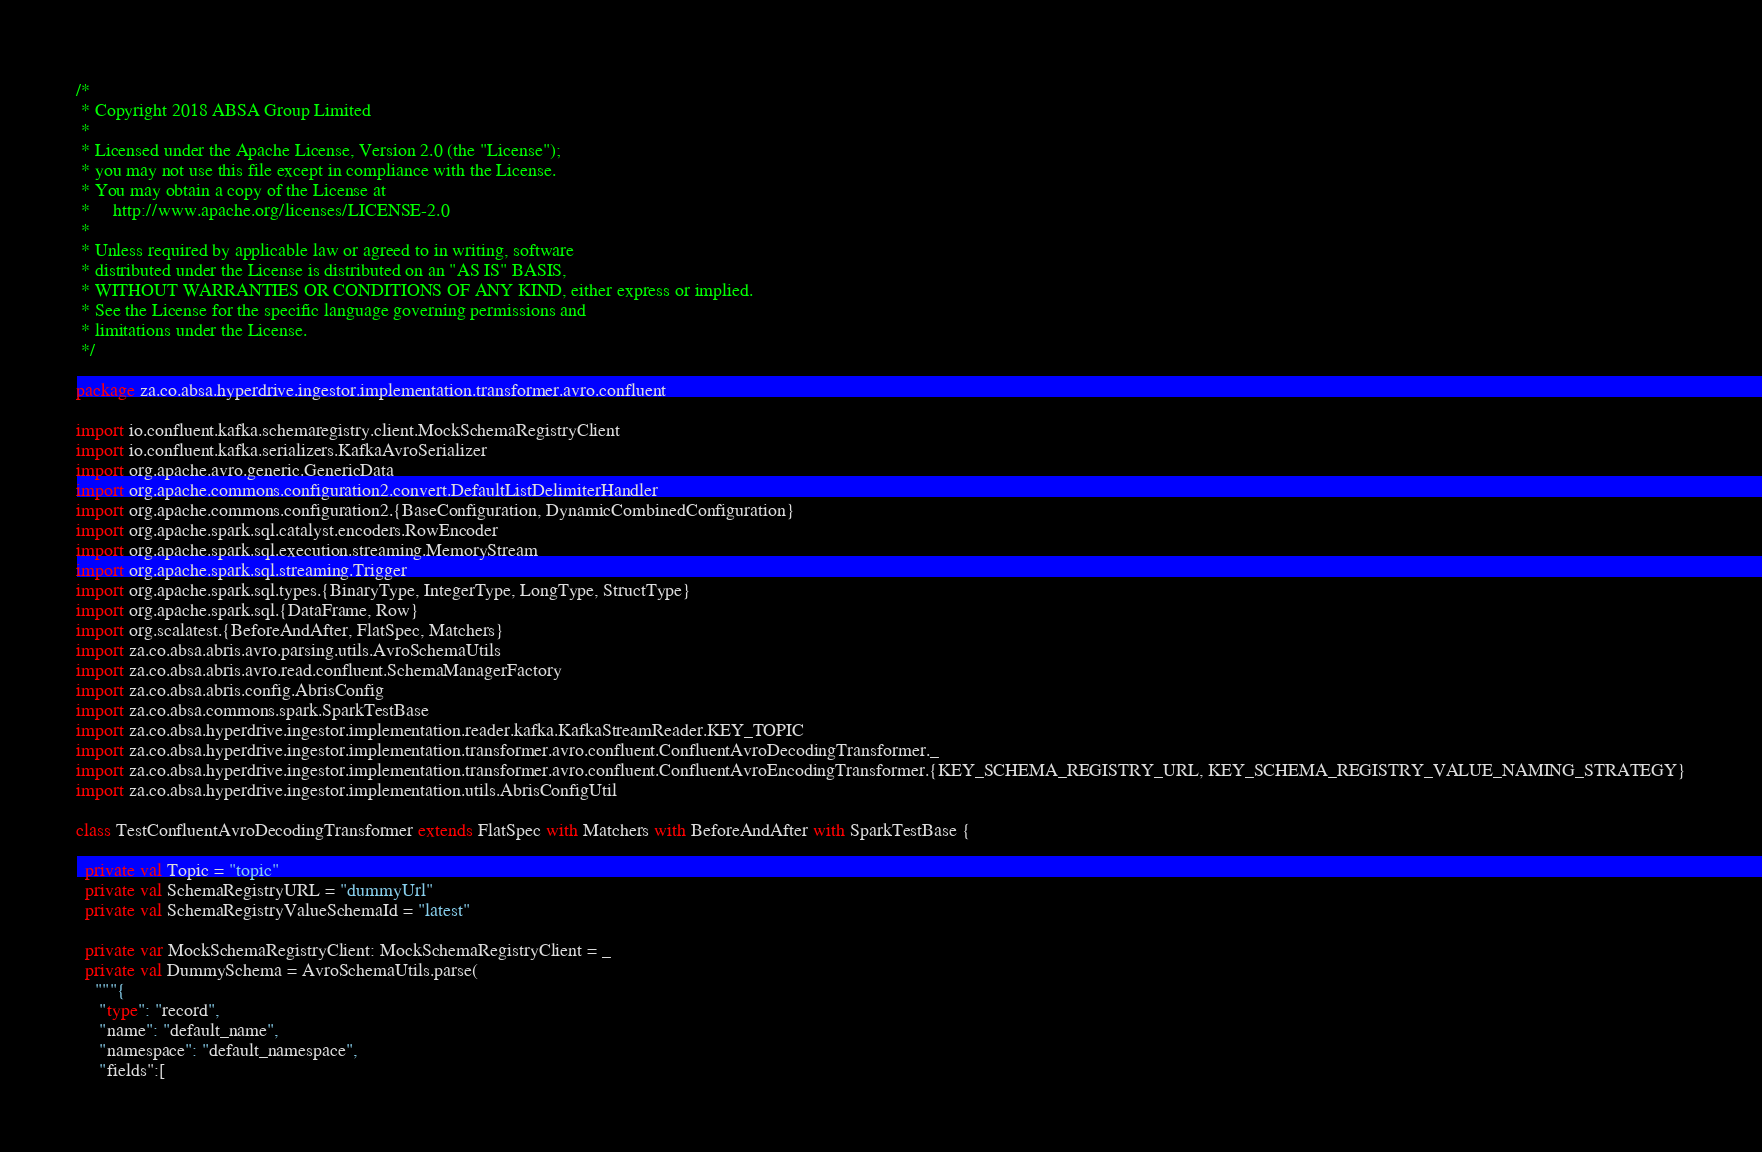<code> <loc_0><loc_0><loc_500><loc_500><_Scala_>/*
 * Copyright 2018 ABSA Group Limited
 *
 * Licensed under the Apache License, Version 2.0 (the "License");
 * you may not use this file except in compliance with the License.
 * You may obtain a copy of the License at
 *     http://www.apache.org/licenses/LICENSE-2.0
 *
 * Unless required by applicable law or agreed to in writing, software
 * distributed under the License is distributed on an "AS IS" BASIS,
 * WITHOUT WARRANTIES OR CONDITIONS OF ANY KIND, either express or implied.
 * See the License for the specific language governing permissions and
 * limitations under the License.
 */

package za.co.absa.hyperdrive.ingestor.implementation.transformer.avro.confluent

import io.confluent.kafka.schemaregistry.client.MockSchemaRegistryClient
import io.confluent.kafka.serializers.KafkaAvroSerializer
import org.apache.avro.generic.GenericData
import org.apache.commons.configuration2.convert.DefaultListDelimiterHandler
import org.apache.commons.configuration2.{BaseConfiguration, DynamicCombinedConfiguration}
import org.apache.spark.sql.catalyst.encoders.RowEncoder
import org.apache.spark.sql.execution.streaming.MemoryStream
import org.apache.spark.sql.streaming.Trigger
import org.apache.spark.sql.types.{BinaryType, IntegerType, LongType, StructType}
import org.apache.spark.sql.{DataFrame, Row}
import org.scalatest.{BeforeAndAfter, FlatSpec, Matchers}
import za.co.absa.abris.avro.parsing.utils.AvroSchemaUtils
import za.co.absa.abris.avro.read.confluent.SchemaManagerFactory
import za.co.absa.abris.config.AbrisConfig
import za.co.absa.commons.spark.SparkTestBase
import za.co.absa.hyperdrive.ingestor.implementation.reader.kafka.KafkaStreamReader.KEY_TOPIC
import za.co.absa.hyperdrive.ingestor.implementation.transformer.avro.confluent.ConfluentAvroDecodingTransformer._
import za.co.absa.hyperdrive.ingestor.implementation.transformer.avro.confluent.ConfluentAvroEncodingTransformer.{KEY_SCHEMA_REGISTRY_URL, KEY_SCHEMA_REGISTRY_VALUE_NAMING_STRATEGY}
import za.co.absa.hyperdrive.ingestor.implementation.utils.AbrisConfigUtil

class TestConfluentAvroDecodingTransformer extends FlatSpec with Matchers with BeforeAndAfter with SparkTestBase {

  private val Topic = "topic"
  private val SchemaRegistryURL = "dummyUrl"
  private val SchemaRegistryValueSchemaId = "latest"

  private var MockSchemaRegistryClient: MockSchemaRegistryClient = _
  private val DummySchema = AvroSchemaUtils.parse(
    """{
     "type": "record",
     "name": "default_name",
     "namespace": "default_namespace",
     "fields":[</code> 